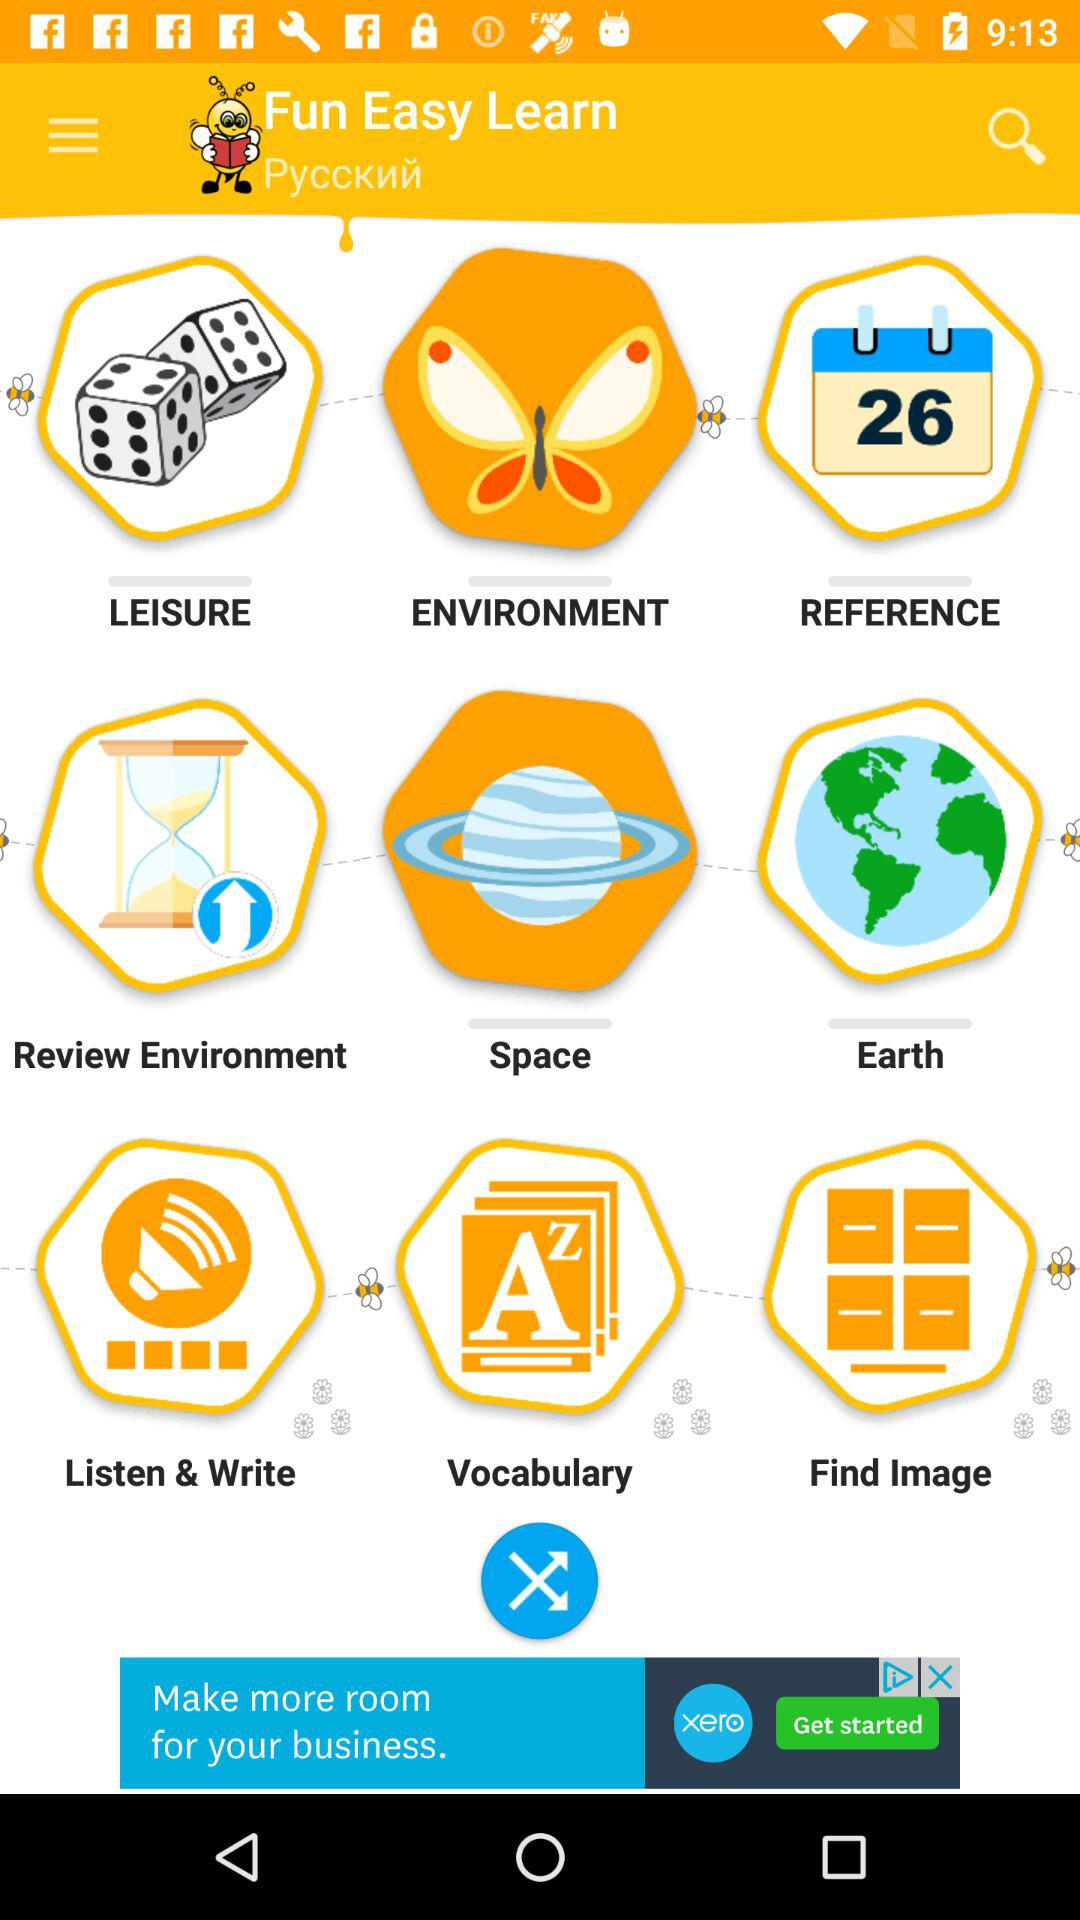How many items are in the second row?
Answer the question using a single word or phrase. 3 